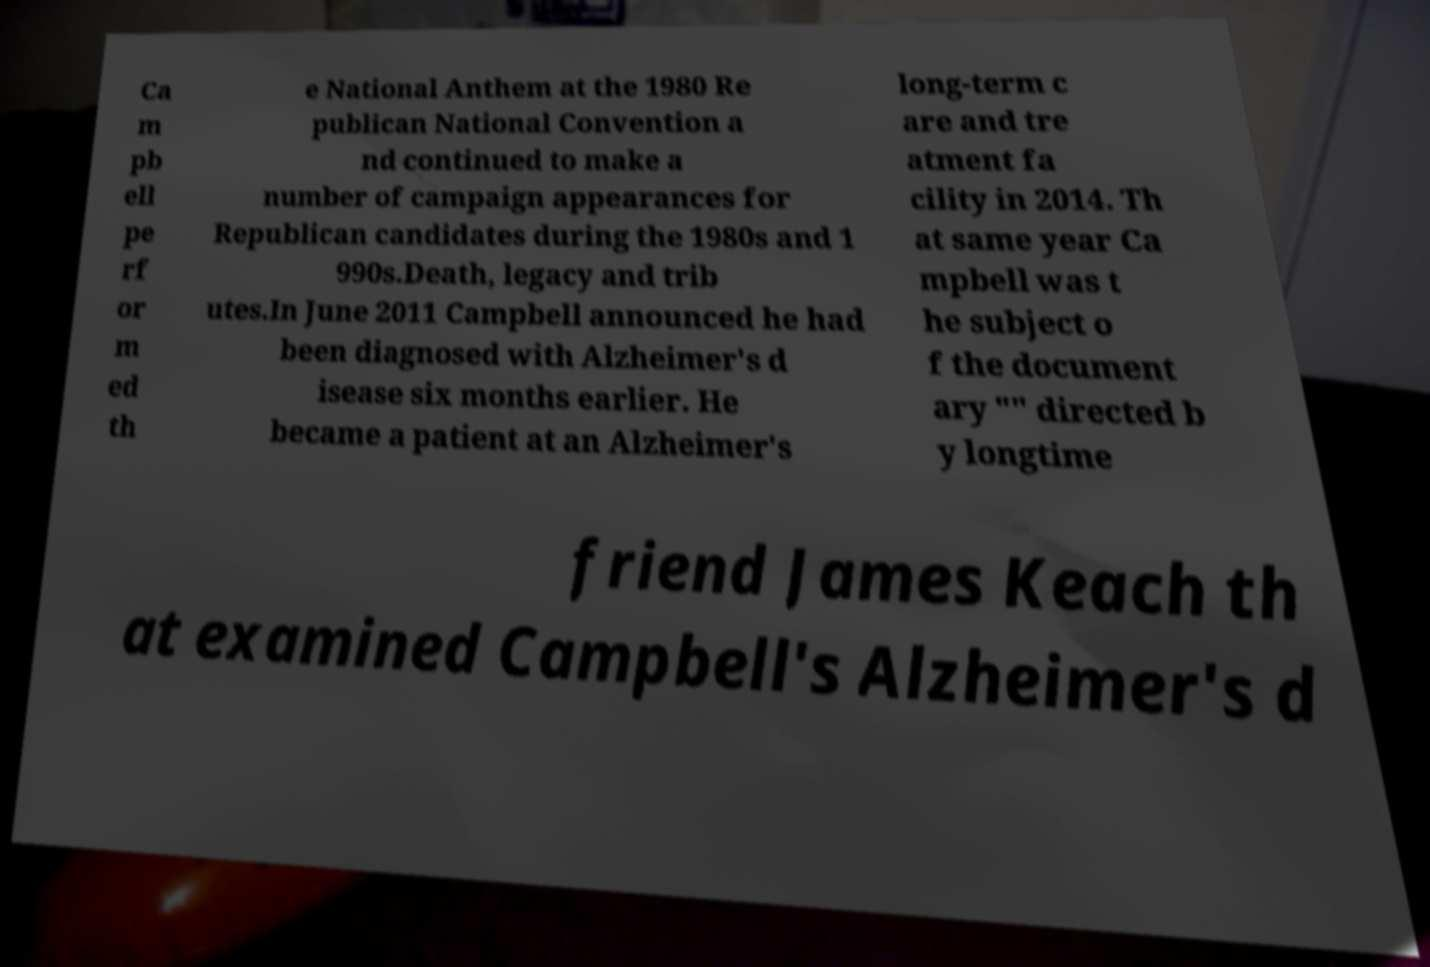Please read and relay the text visible in this image. What does it say? Ca m pb ell pe rf or m ed th e National Anthem at the 1980 Re publican National Convention a nd continued to make a number of campaign appearances for Republican candidates during the 1980s and 1 990s.Death, legacy and trib utes.In June 2011 Campbell announced he had been diagnosed with Alzheimer's d isease six months earlier. He became a patient at an Alzheimer's long-term c are and tre atment fa cility in 2014. Th at same year Ca mpbell was t he subject o f the document ary "" directed b y longtime friend James Keach th at examined Campbell's Alzheimer's d 